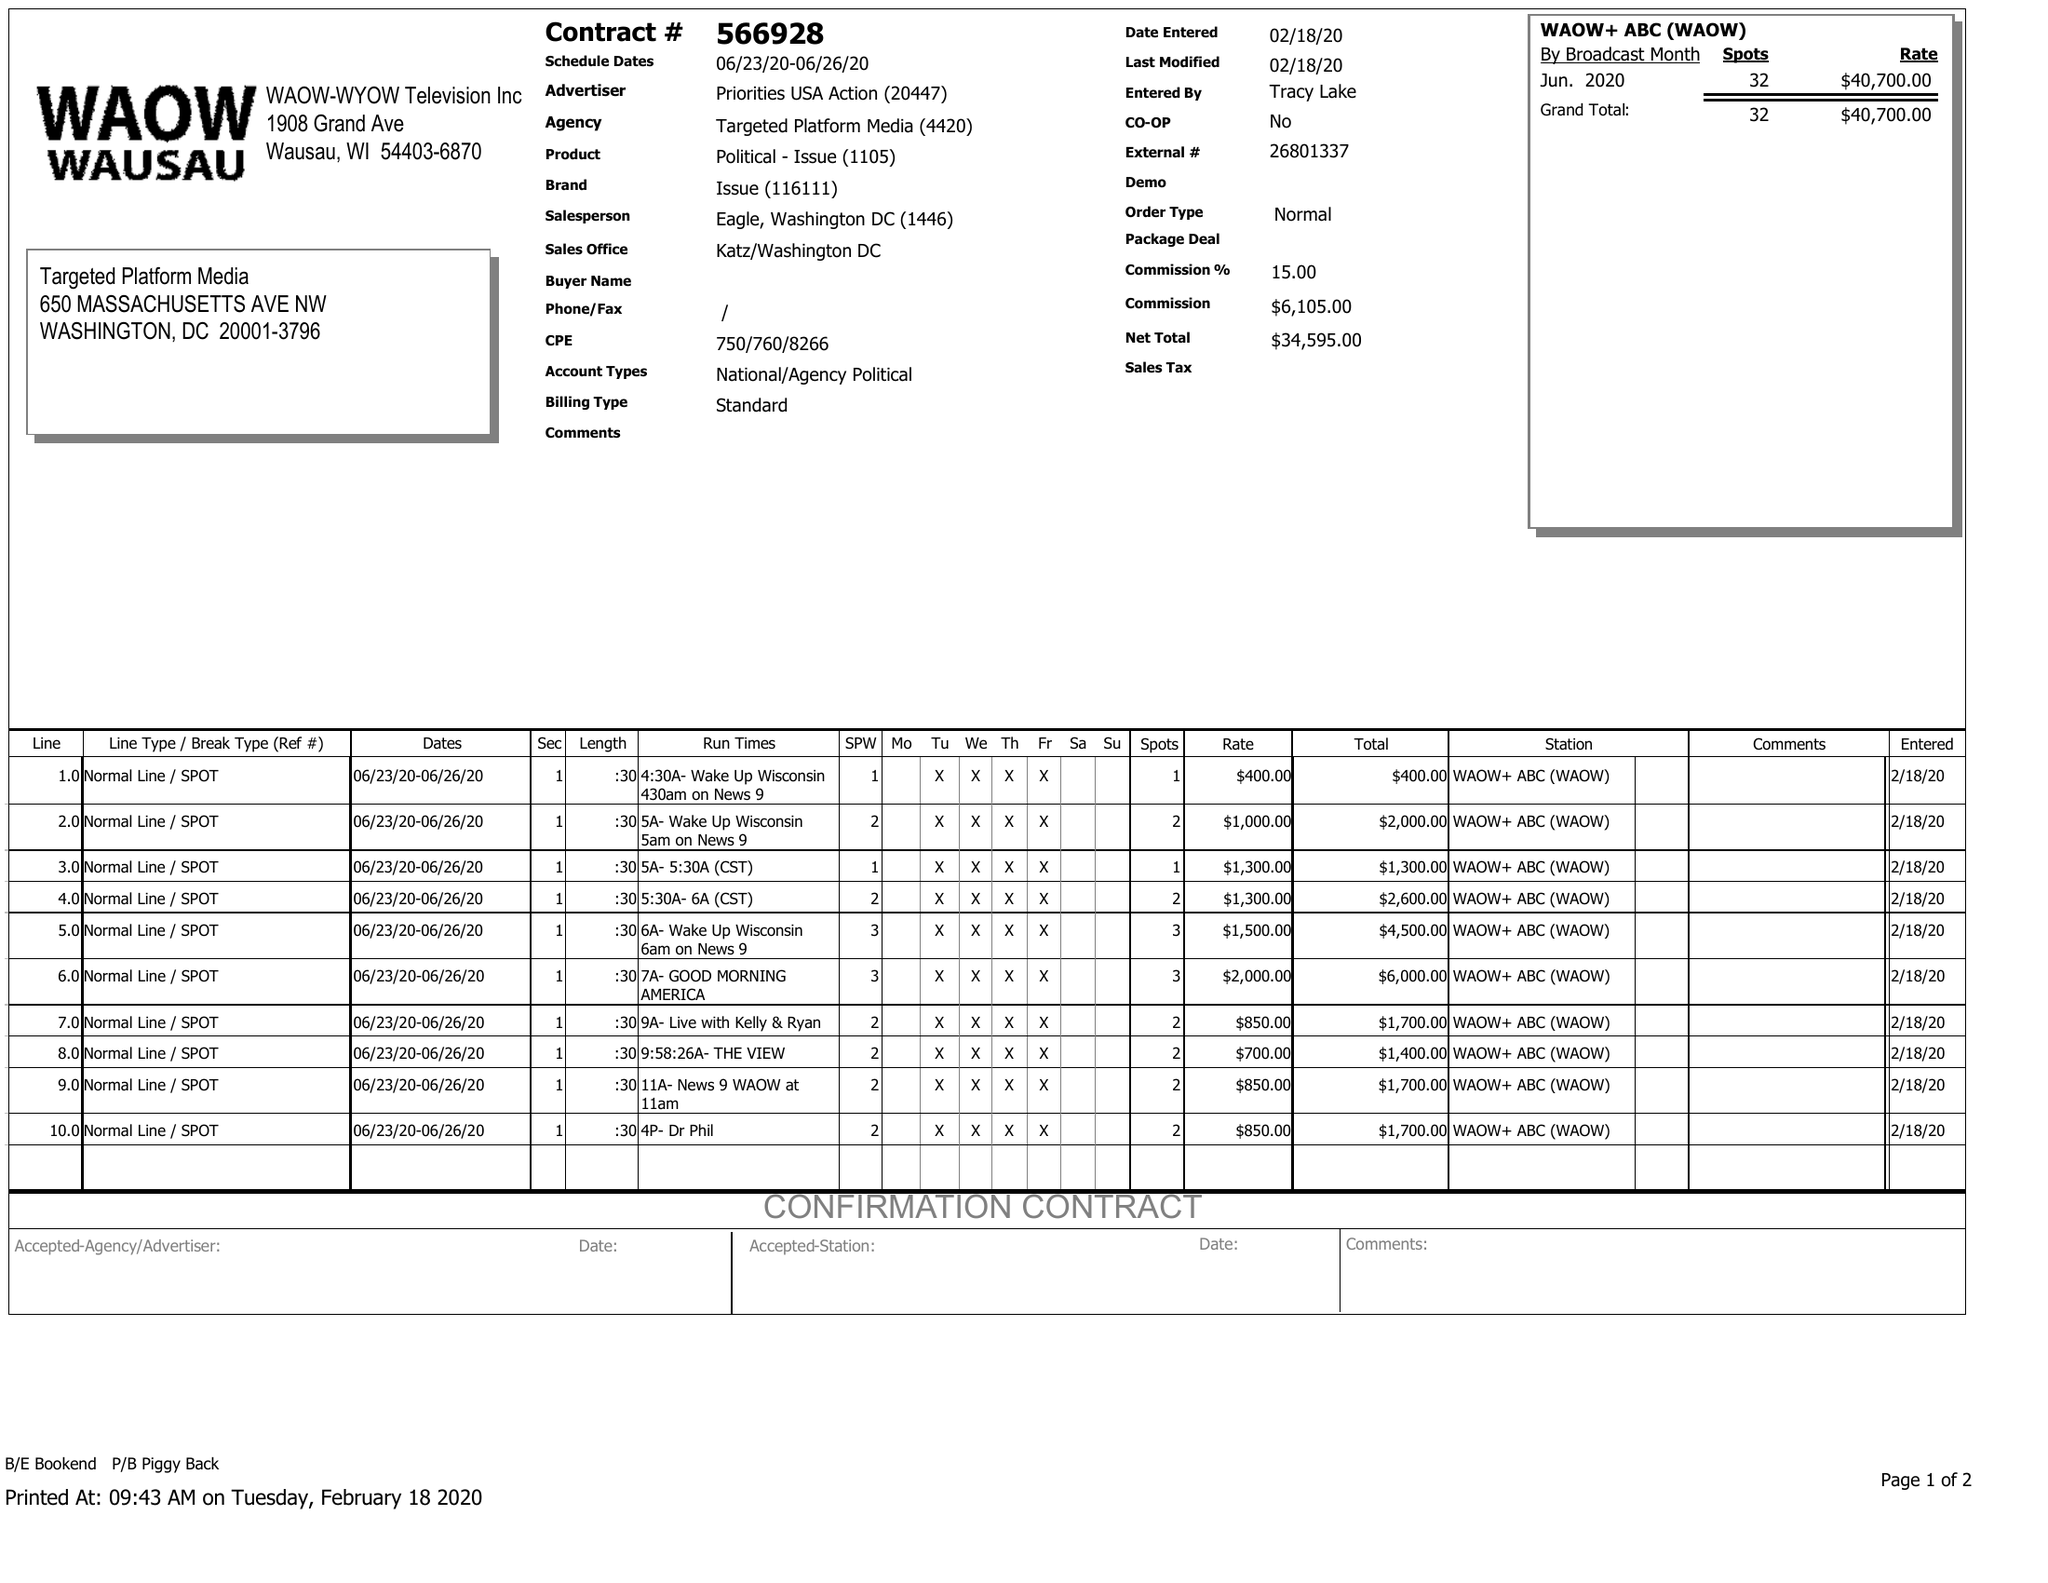What is the value for the flight_to?
Answer the question using a single word or phrase. 06/26/20 